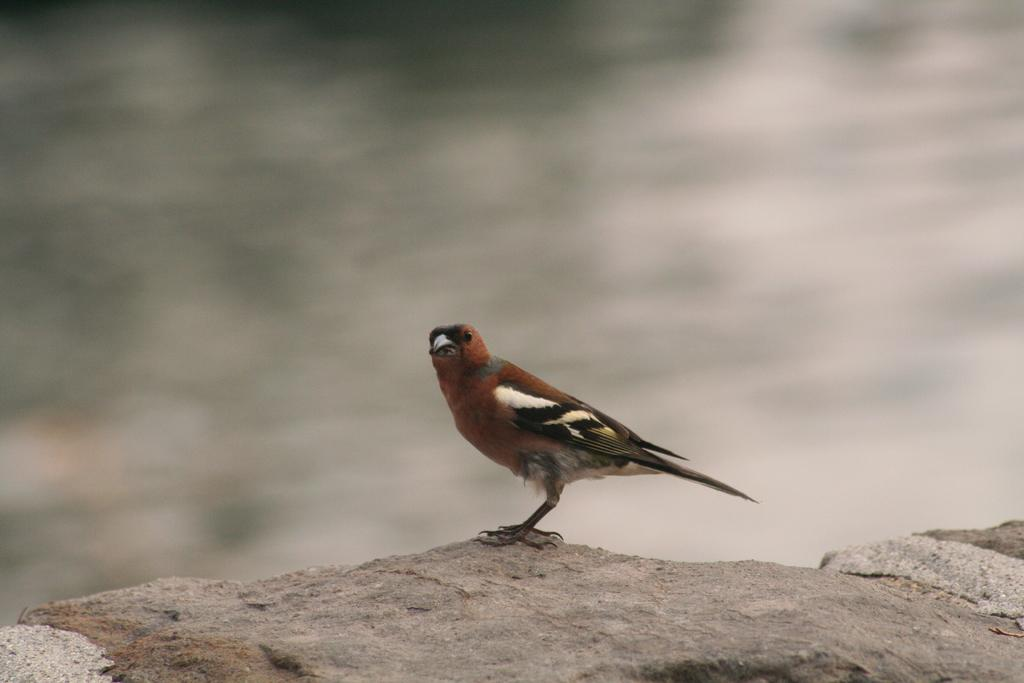What type of animal is in the image? There is a bird in the image. What colors can be seen on the bird? The bird is in brown and black colors. What is the bird standing on? The bird is standing on a rock. How would you describe the background of the image? The background of the image is blurred. What type of brick is the bird using to build its nest in the image? There is no brick or nest present in the image; it features a bird standing on a rock. Can you see a train passing by in the background of the image? There is no train visible in the image; the background is blurred. 